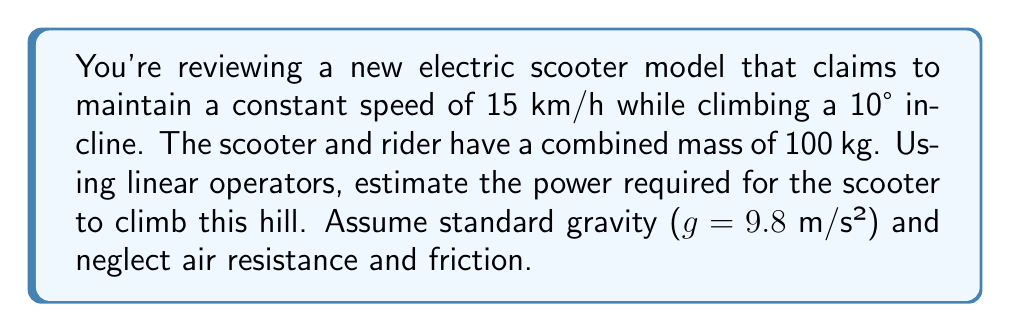Give your solution to this math problem. To solve this problem, we'll use linear operators to break down the forces acting on the scooter-rider system and calculate the power required. Let's approach this step-by-step:

1) First, we need to convert the speed from km/h to m/s:
   $15$ km/h = $15 \times \frac{1000}{3600}$ m/s = $4.17$ m/s

2) Now, let's define our linear operator $F$ that represents the force acting on the system. This operator will have two components:
   - The force parallel to the incline (which we need to overcome)
   - The force perpendicular to the incline (which doesn't affect our power calculation)

3) The force parallel to the incline is given by:
   $F_{\parallel} = mg \sin(\theta)$
   Where $m$ is the mass, $g$ is gravity, and $\theta$ is the angle of incline.

4) Plugging in our values:
   $F_{\parallel} = 100 \times 9.8 \times \sin(10°) = 170.1$ N

5) The power required is given by the dot product of the force and velocity vectors:
   $P = F \cdot v = F_{\parallel} v$

6) Calculating the power:
   $P = 170.1 \times 4.17 = 709.3$ W

7) Converting to kilowatts:
   $P = 709.3 \div 1000 = 0.7093$ kW

Therefore, the estimated power required for the electric scooter to maintain a constant speed of 15 km/h while climbing a 10° incline is approximately 0.71 kW.
Answer: $$P \approx 0.71 \text{ kW}$$ 